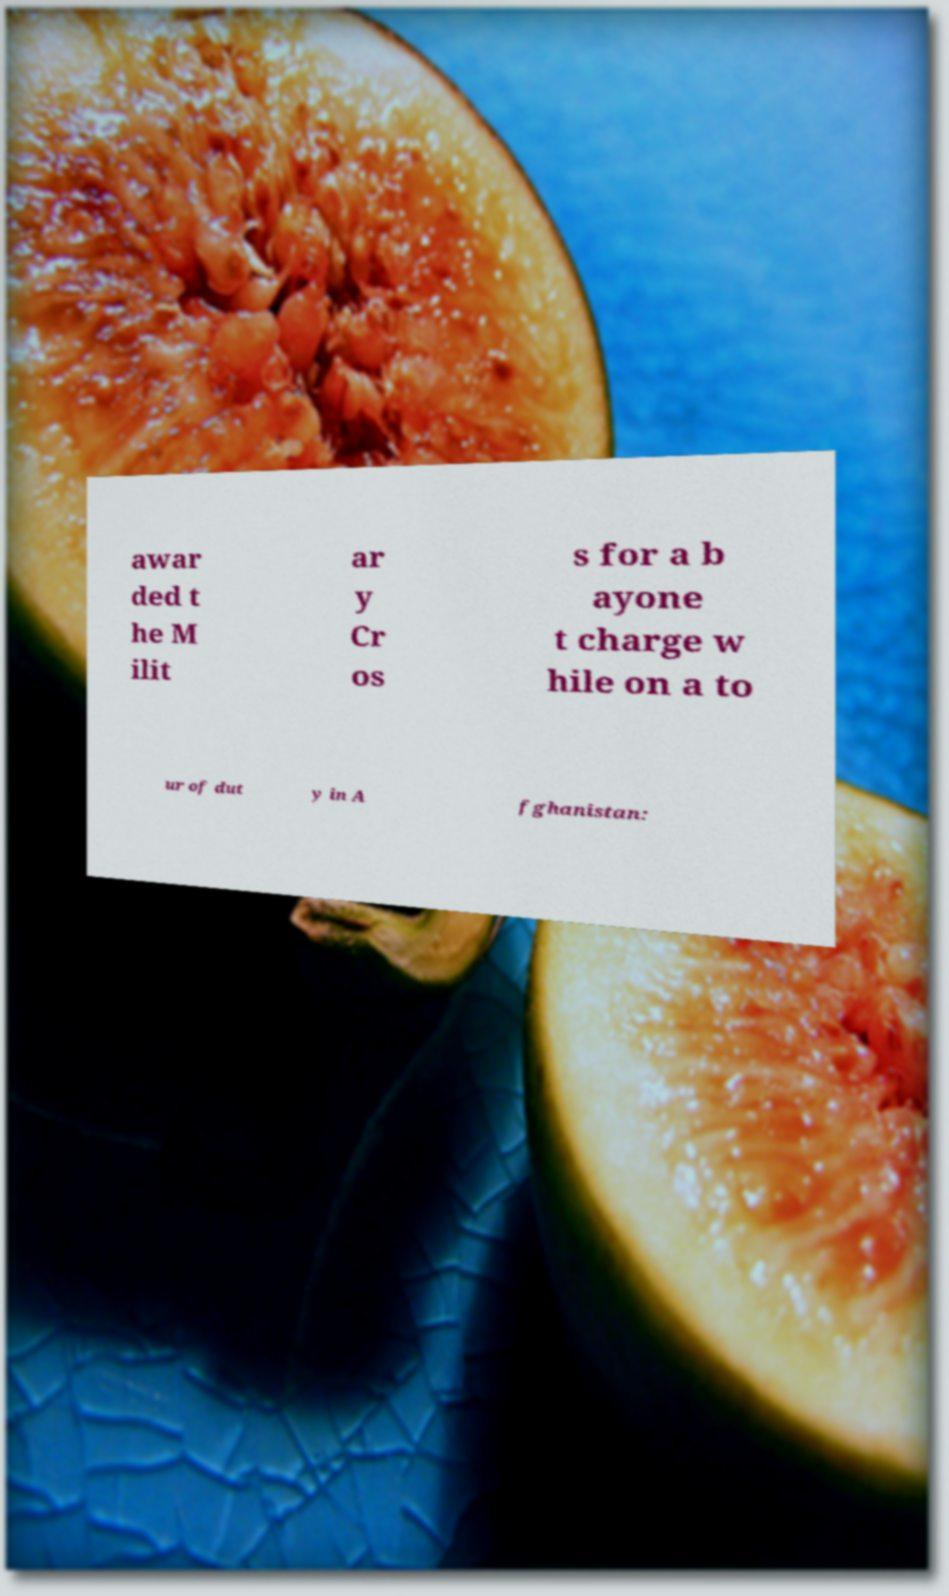For documentation purposes, I need the text within this image transcribed. Could you provide that? awar ded t he M ilit ar y Cr os s for a b ayone t charge w hile on a to ur of dut y in A fghanistan: 